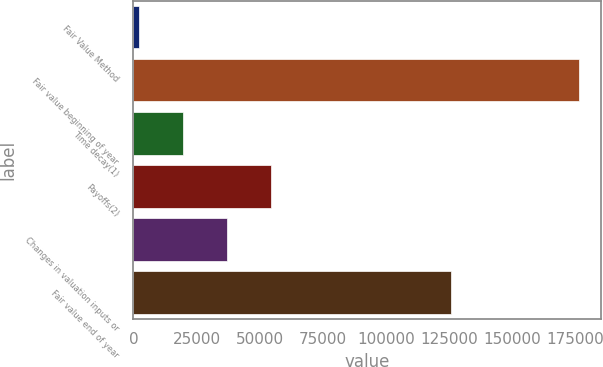Convert chart. <chart><loc_0><loc_0><loc_500><loc_500><bar_chart><fcel>Fair Value Method<fcel>Fair value beginning of year<fcel>Time decay(1)<fcel>Payoffs(2)<fcel>Changes in valuation inputs or<fcel>Fair value end of year<nl><fcel>2010<fcel>176427<fcel>19451.7<fcel>54335.1<fcel>36893.4<fcel>125679<nl></chart> 